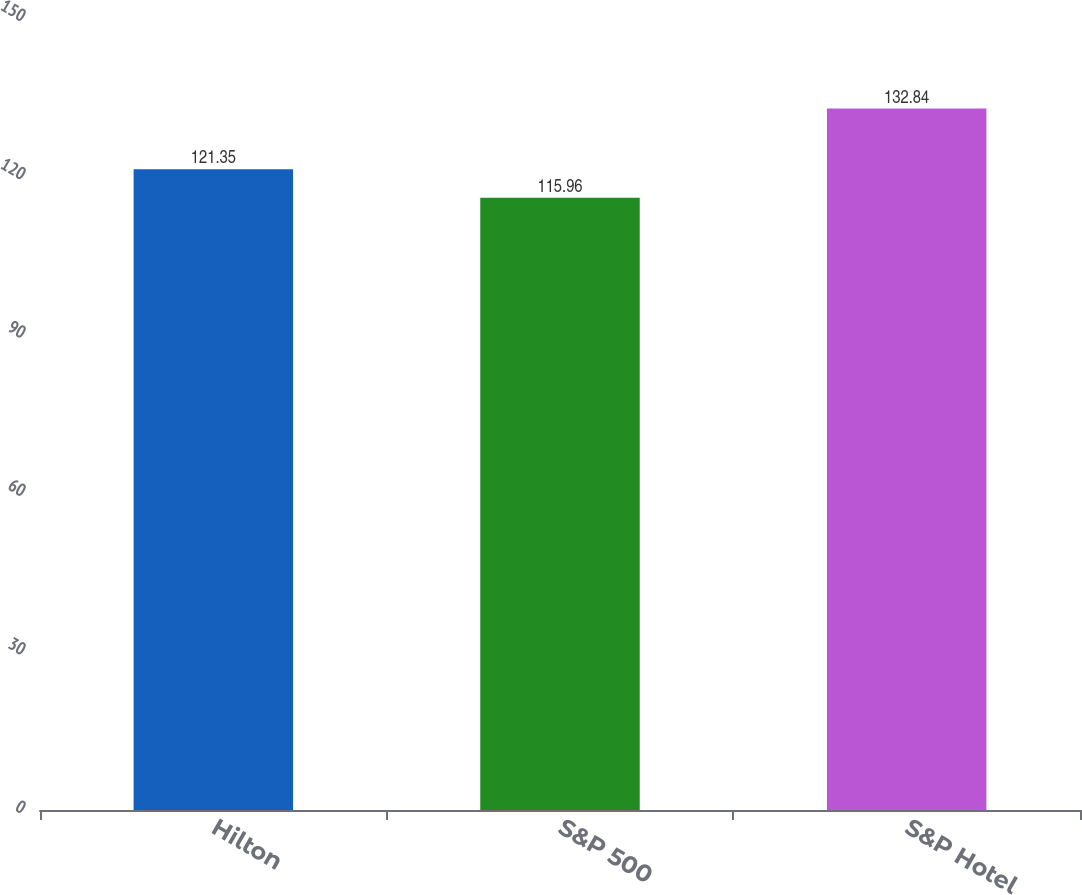Convert chart to OTSL. <chart><loc_0><loc_0><loc_500><loc_500><bar_chart><fcel>Hilton<fcel>S&P 500<fcel>S&P Hotel<nl><fcel>121.35<fcel>115.96<fcel>132.84<nl></chart> 